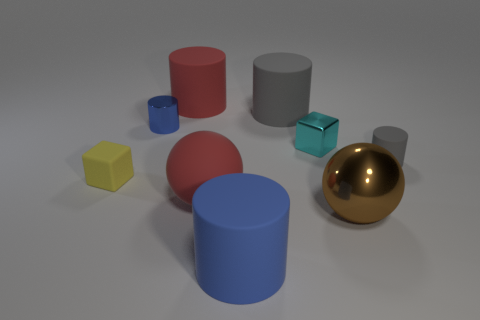There is a large brown metallic thing; are there any yellow things to the left of it?
Your answer should be very brief. Yes. Are there more blue metallic objects right of the yellow rubber object than big metallic things to the left of the large blue thing?
Your answer should be compact. Yes. What is the size of the blue matte object that is the same shape as the small gray rubber object?
Offer a very short reply. Large. How many cylinders are large red shiny things or big blue rubber objects?
Give a very brief answer. 1. There is a large object that is the same color as the metal cylinder; what is it made of?
Your answer should be compact. Rubber. Is the number of big red rubber cylinders that are right of the small rubber cylinder less than the number of brown shiny things that are left of the blue metal object?
Provide a succinct answer. No. How many objects are tiny blocks that are behind the small yellow rubber block or tiny blue matte objects?
Provide a short and direct response. 1. What shape is the red matte object in front of the blue thing that is behind the blue rubber cylinder?
Your answer should be compact. Sphere. Are there any blue matte cylinders of the same size as the blue rubber object?
Your answer should be compact. No. Is the number of tiny shiny cylinders greater than the number of objects?
Give a very brief answer. No. 